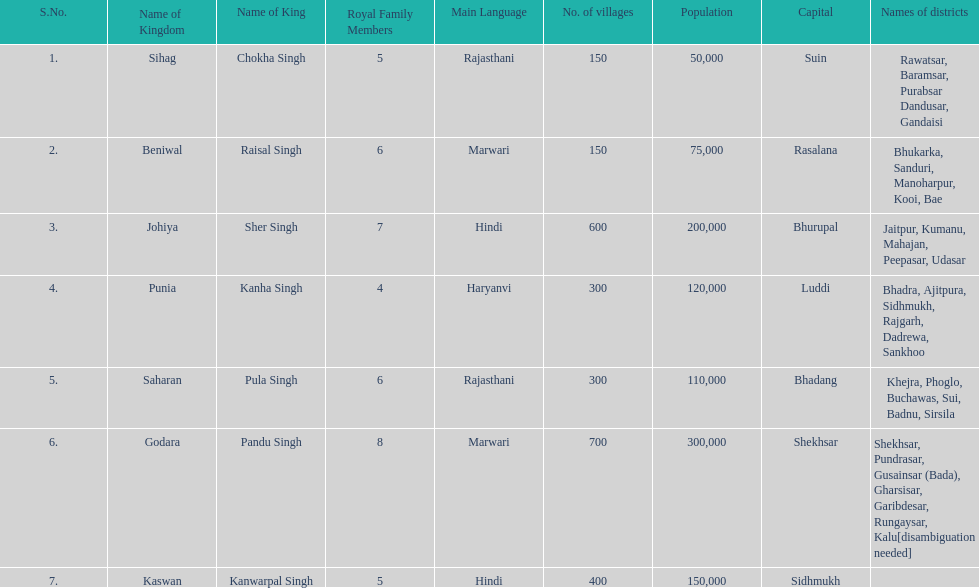What is the next kingdom listed after sihag? Beniwal. 